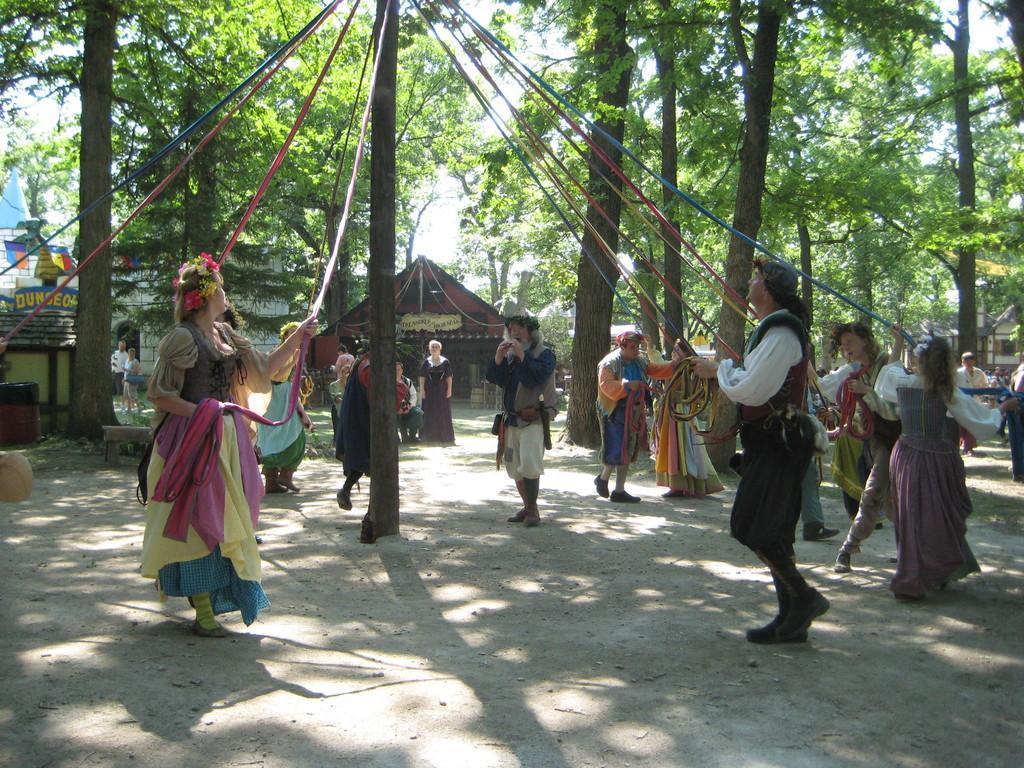In one or two sentences, can you explain what this image depicts? In this image in the center there are some people who are standing, and they are holding ropes. In the center there is one pole, in the background there are some tents, boards and buildings and also there are some trees. At the bottom there is sand. 